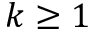<formula> <loc_0><loc_0><loc_500><loc_500>k \geq 1</formula> 